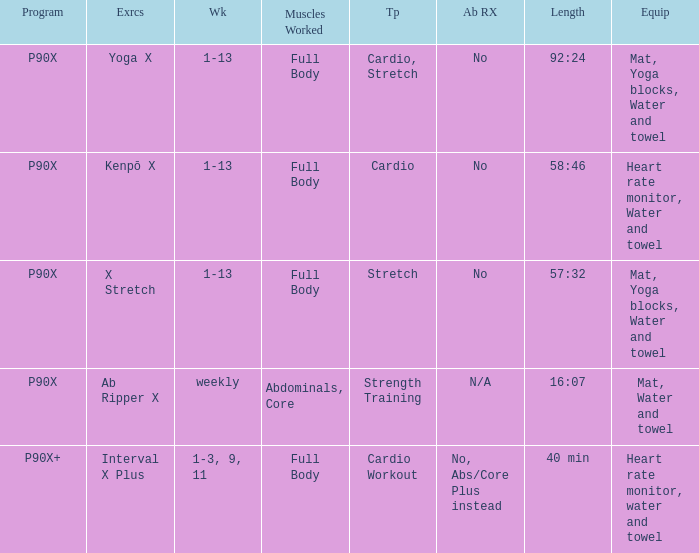What is the ab ripper x when exercise is x stretch? No. 